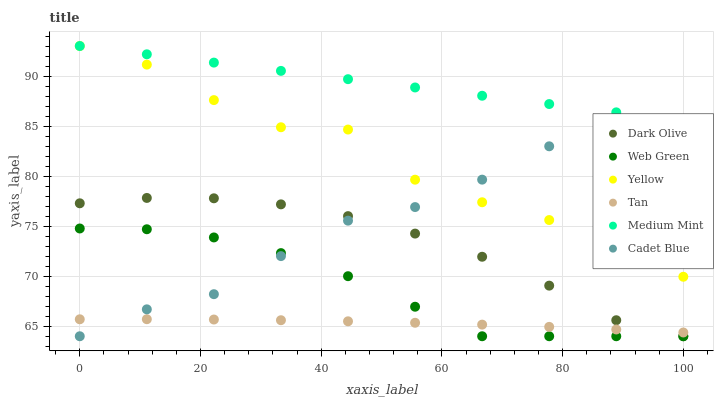Does Tan have the minimum area under the curve?
Answer yes or no. Yes. Does Medium Mint have the maximum area under the curve?
Answer yes or no. Yes. Does Cadet Blue have the minimum area under the curve?
Answer yes or no. No. Does Cadet Blue have the maximum area under the curve?
Answer yes or no. No. Is Medium Mint the smoothest?
Answer yes or no. Yes. Is Yellow the roughest?
Answer yes or no. Yes. Is Cadet Blue the smoothest?
Answer yes or no. No. Is Cadet Blue the roughest?
Answer yes or no. No. Does Cadet Blue have the lowest value?
Answer yes or no. Yes. Does Yellow have the lowest value?
Answer yes or no. No. Does Yellow have the highest value?
Answer yes or no. Yes. Does Cadet Blue have the highest value?
Answer yes or no. No. Is Dark Olive less than Medium Mint?
Answer yes or no. Yes. Is Yellow greater than Dark Olive?
Answer yes or no. Yes. Does Dark Olive intersect Web Green?
Answer yes or no. Yes. Is Dark Olive less than Web Green?
Answer yes or no. No. Is Dark Olive greater than Web Green?
Answer yes or no. No. Does Dark Olive intersect Medium Mint?
Answer yes or no. No. 